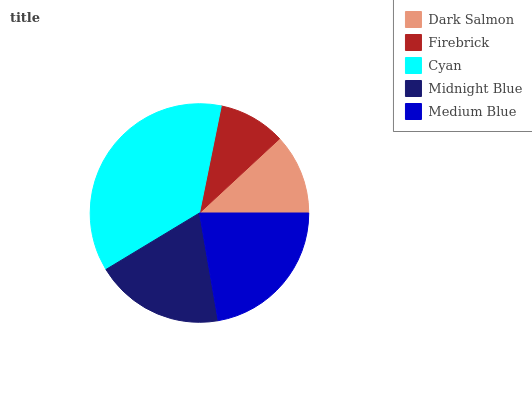Is Firebrick the minimum?
Answer yes or no. Yes. Is Cyan the maximum?
Answer yes or no. Yes. Is Cyan the minimum?
Answer yes or no. No. Is Firebrick the maximum?
Answer yes or no. No. Is Cyan greater than Firebrick?
Answer yes or no. Yes. Is Firebrick less than Cyan?
Answer yes or no. Yes. Is Firebrick greater than Cyan?
Answer yes or no. No. Is Cyan less than Firebrick?
Answer yes or no. No. Is Midnight Blue the high median?
Answer yes or no. Yes. Is Midnight Blue the low median?
Answer yes or no. Yes. Is Firebrick the high median?
Answer yes or no. No. Is Cyan the low median?
Answer yes or no. No. 